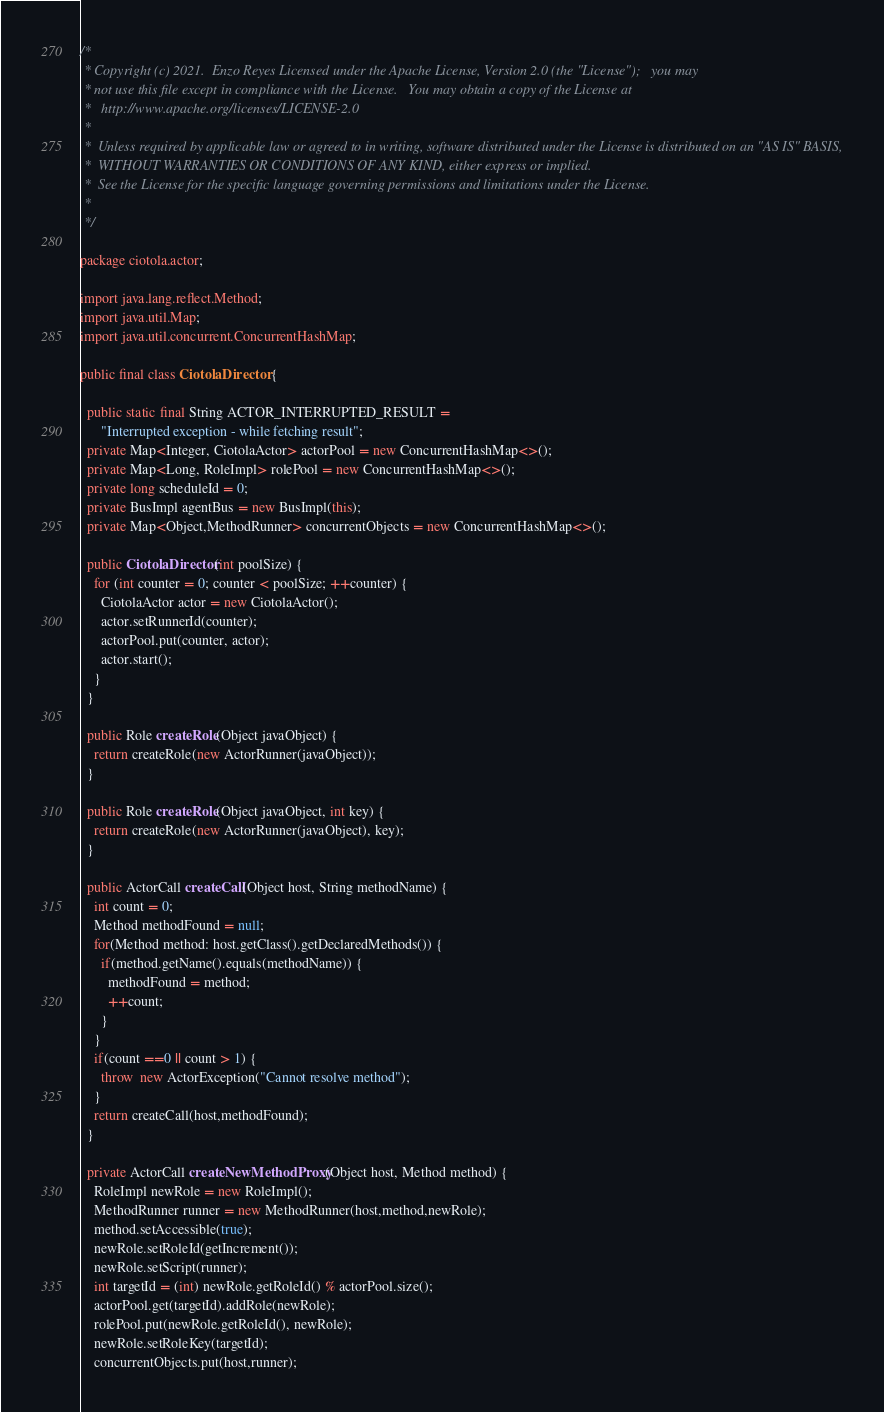Convert code to text. <code><loc_0><loc_0><loc_500><loc_500><_Java_>/*
 * Copyright (c) 2021.  Enzo Reyes Licensed under the Apache License, Version 2.0 (the "License");   you may
 * not use this file except in compliance with the License.   You may obtain a copy of the License at
 *   http://www.apache.org/licenses/LICENSE-2.0
 *
 *  Unless required by applicable law or agreed to in writing, software distributed under the License is distributed on an "AS IS" BASIS,
 *  WITHOUT WARRANTIES OR CONDITIONS OF ANY KIND, either express or implied.
 *  See the License for the specific language governing permissions and limitations under the License.
 *
 */

package ciotola.actor;

import java.lang.reflect.Method;
import java.util.Map;
import java.util.concurrent.ConcurrentHashMap;

public final class CiotolaDirector {

  public static final String ACTOR_INTERRUPTED_RESULT =
      "Interrupted exception - while fetching result";
  private Map<Integer, CiotolaActor> actorPool = new ConcurrentHashMap<>();
  private Map<Long, RoleImpl> rolePool = new ConcurrentHashMap<>();
  private long scheduleId = 0;
  private BusImpl agentBus = new BusImpl(this);
  private Map<Object,MethodRunner> concurrentObjects = new ConcurrentHashMap<>();

  public CiotolaDirector(int poolSize) {
    for (int counter = 0; counter < poolSize; ++counter) {
      CiotolaActor actor = new CiotolaActor();
      actor.setRunnerId(counter);
      actorPool.put(counter, actor);
      actor.start();
    }
  }

  public Role createRole(Object javaObject) {
    return createRole(new ActorRunner(javaObject));
  }

  public Role createRole(Object javaObject, int key) {
    return createRole(new ActorRunner(javaObject), key);
  }

  public ActorCall createCall(Object host, String methodName) {
    int count = 0;
    Method methodFound = null;
    for(Method method: host.getClass().getDeclaredMethods()) {
      if(method.getName().equals(methodName)) {
        methodFound = method;
        ++count;
      }
    }
    if(count ==0 || count > 1) {
      throw  new ActorException("Cannot resolve method");
    }
    return createCall(host,methodFound);
  }

  private ActorCall createNewMethodProxy(Object host, Method method) {
    RoleImpl newRole = new RoleImpl();
    MethodRunner runner = new MethodRunner(host,method,newRole);
    method.setAccessible(true);
    newRole.setRoleId(getIncrement());
    newRole.setScript(runner);
    int targetId = (int) newRole.getRoleId() % actorPool.size();
    actorPool.get(targetId).addRole(newRole);
    rolePool.put(newRole.getRoleId(), newRole);
    newRole.setRoleKey(targetId);
    concurrentObjects.put(host,runner);</code> 